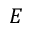Convert formula to latex. <formula><loc_0><loc_0><loc_500><loc_500>E</formula> 